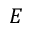Convert formula to latex. <formula><loc_0><loc_0><loc_500><loc_500>E</formula> 